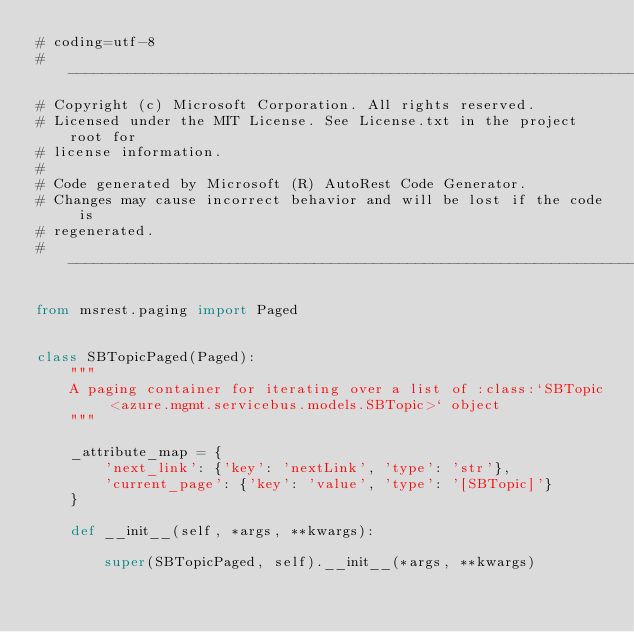Convert code to text. <code><loc_0><loc_0><loc_500><loc_500><_Python_># coding=utf-8
# --------------------------------------------------------------------------
# Copyright (c) Microsoft Corporation. All rights reserved.
# Licensed under the MIT License. See License.txt in the project root for
# license information.
#
# Code generated by Microsoft (R) AutoRest Code Generator.
# Changes may cause incorrect behavior and will be lost if the code is
# regenerated.
# --------------------------------------------------------------------------

from msrest.paging import Paged


class SBTopicPaged(Paged):
    """
    A paging container for iterating over a list of :class:`SBTopic <azure.mgmt.servicebus.models.SBTopic>` object
    """

    _attribute_map = {
        'next_link': {'key': 'nextLink', 'type': 'str'},
        'current_page': {'key': 'value', 'type': '[SBTopic]'}
    }

    def __init__(self, *args, **kwargs):

        super(SBTopicPaged, self).__init__(*args, **kwargs)
</code> 